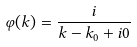Convert formula to latex. <formula><loc_0><loc_0><loc_500><loc_500>\varphi ( k ) = \frac { i } { k - k _ { 0 } + i 0 }</formula> 